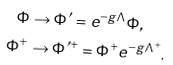Convert formula to latex. <formula><loc_0><loc_0><loc_500><loc_500>\Phi & \rightarrow \Phi ^ { \prime } = e ^ { - g \Lambda } \Phi , \\ \Phi ^ { + } & \rightarrow \Phi ^ { \prime + } = \Phi ^ { + } e ^ { - g \Lambda ^ { + } } . \\</formula> 